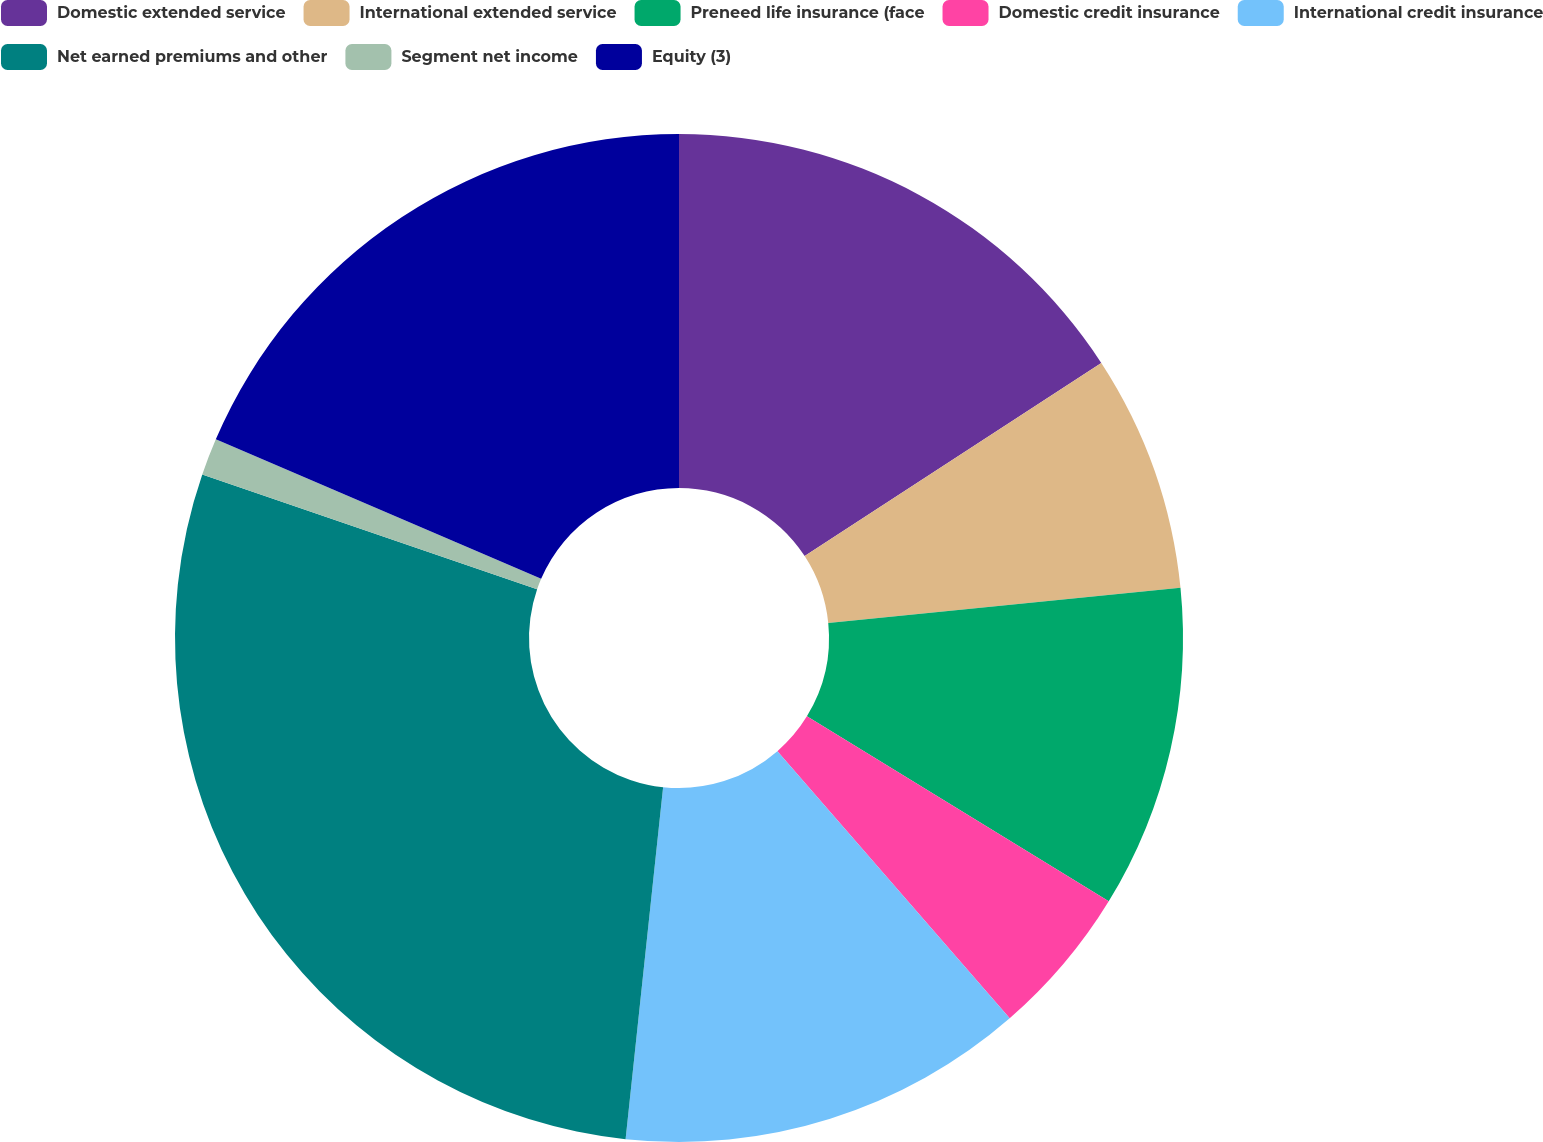Convert chart. <chart><loc_0><loc_0><loc_500><loc_500><pie_chart><fcel>Domestic extended service<fcel>International extended service<fcel>Preneed life insurance (face<fcel>Domestic credit insurance<fcel>International credit insurance<fcel>Net earned premiums and other<fcel>Segment net income<fcel>Equity (3)<nl><fcel>15.81%<fcel>7.6%<fcel>10.34%<fcel>4.86%<fcel>13.08%<fcel>28.57%<fcel>1.19%<fcel>18.55%<nl></chart> 